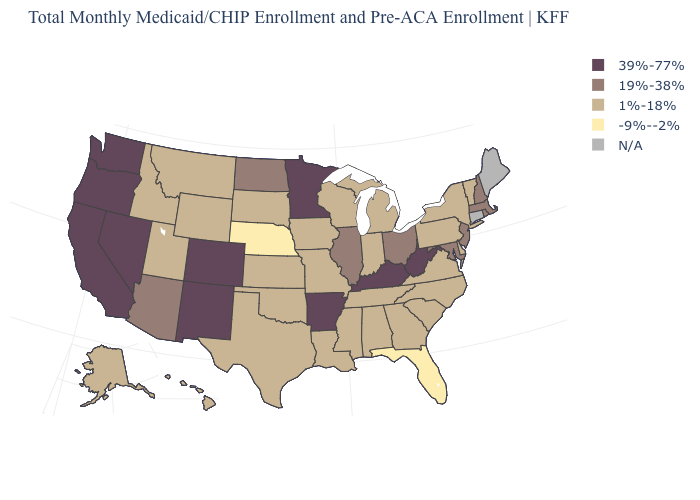What is the highest value in the USA?
Short answer required. 39%-77%. Is the legend a continuous bar?
Answer briefly. No. What is the value of Pennsylvania?
Short answer required. 1%-18%. What is the lowest value in the USA?
Write a very short answer. -9%--2%. What is the lowest value in the USA?
Concise answer only. -9%--2%. Which states hav the highest value in the South?
Be succinct. Arkansas, Kentucky, West Virginia. Is the legend a continuous bar?
Be succinct. No. Name the states that have a value in the range 1%-18%?
Concise answer only. Alabama, Alaska, Delaware, Georgia, Hawaii, Idaho, Indiana, Iowa, Kansas, Louisiana, Michigan, Mississippi, Missouri, Montana, New York, North Carolina, Oklahoma, Pennsylvania, South Carolina, South Dakota, Tennessee, Texas, Utah, Vermont, Virginia, Wisconsin, Wyoming. How many symbols are there in the legend?
Write a very short answer. 5. What is the value of Indiana?
Keep it brief. 1%-18%. Name the states that have a value in the range 39%-77%?
Keep it brief. Arkansas, California, Colorado, Kentucky, Minnesota, Nevada, New Mexico, Oregon, Washington, West Virginia. Among the states that border Michigan , which have the highest value?
Short answer required. Ohio. Name the states that have a value in the range -9%--2%?
Be succinct. Florida, Nebraska. Name the states that have a value in the range 19%-38%?
Give a very brief answer. Arizona, Illinois, Maryland, Massachusetts, New Hampshire, New Jersey, North Dakota, Ohio, Rhode Island. 